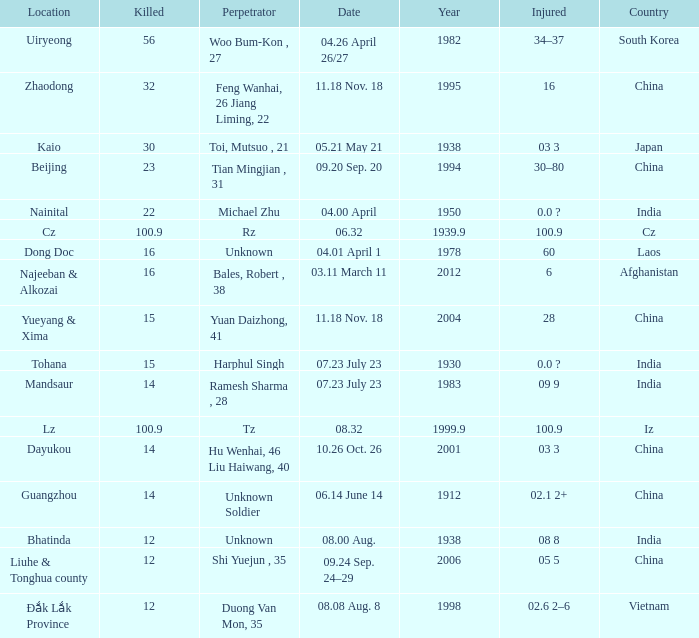What is Injured, when Country is "Afghanistan"? 6.0. Could you help me parse every detail presented in this table? {'header': ['Location', 'Killed', 'Perpetrator', 'Date', 'Year', 'Injured', 'Country'], 'rows': [['Uiryeong', '56', 'Woo Bum-Kon , 27', '04.26 April 26/27', '1982', '34–37', 'South Korea'], ['Zhaodong', '32', 'Feng Wanhai, 26 Jiang Liming, 22', '11.18 Nov. 18', '1995', '16', 'China'], ['Kaio', '30', 'Toi, Mutsuo , 21', '05.21 May 21', '1938', '03 3', 'Japan'], ['Beijing', '23', 'Tian Mingjian , 31', '09.20 Sep. 20', '1994', '30–80', 'China'], ['Nainital', '22', 'Michael Zhu', '04.00 April', '1950', '0.0 ?', 'India'], ['Cz', '100.9', 'Rz', '06.32', '1939.9', '100.9', 'Cz'], ['Dong Doc', '16', 'Unknown', '04.01 April 1', '1978', '60', 'Laos'], ['Najeeban & Alkozai', '16', 'Bales, Robert , 38', '03.11 March 11', '2012', '6', 'Afghanistan'], ['Yueyang & Xima', '15', 'Yuan Daizhong, 41', '11.18 Nov. 18', '2004', '28', 'China'], ['Tohana', '15', 'Harphul Singh', '07.23 July 23', '1930', '0.0 ?', 'India'], ['Mandsaur', '14', 'Ramesh Sharma , 28', '07.23 July 23', '1983', '09 9', 'India'], ['Lz', '100.9', 'Tz', '08.32', '1999.9', '100.9', 'Iz'], ['Dayukou', '14', 'Hu Wenhai, 46 Liu Haiwang, 40', '10.26 Oct. 26', '2001', '03 3', 'China'], ['Guangzhou', '14', 'Unknown Soldier', '06.14 June 14', '1912', '02.1 2+', 'China'], ['Bhatinda', '12', 'Unknown', '08.00 Aug.', '1938', '08 8', 'India'], ['Liuhe & Tonghua county', '12', 'Shi Yuejun , 35', '09.24 Sep. 24–29', '2006', '05 5', 'China'], ['Đắk Lắk Province', '12', 'Duong Van Mon, 35', '08.08 Aug. 8', '1998', '02.6 2–6', 'Vietnam']]} 